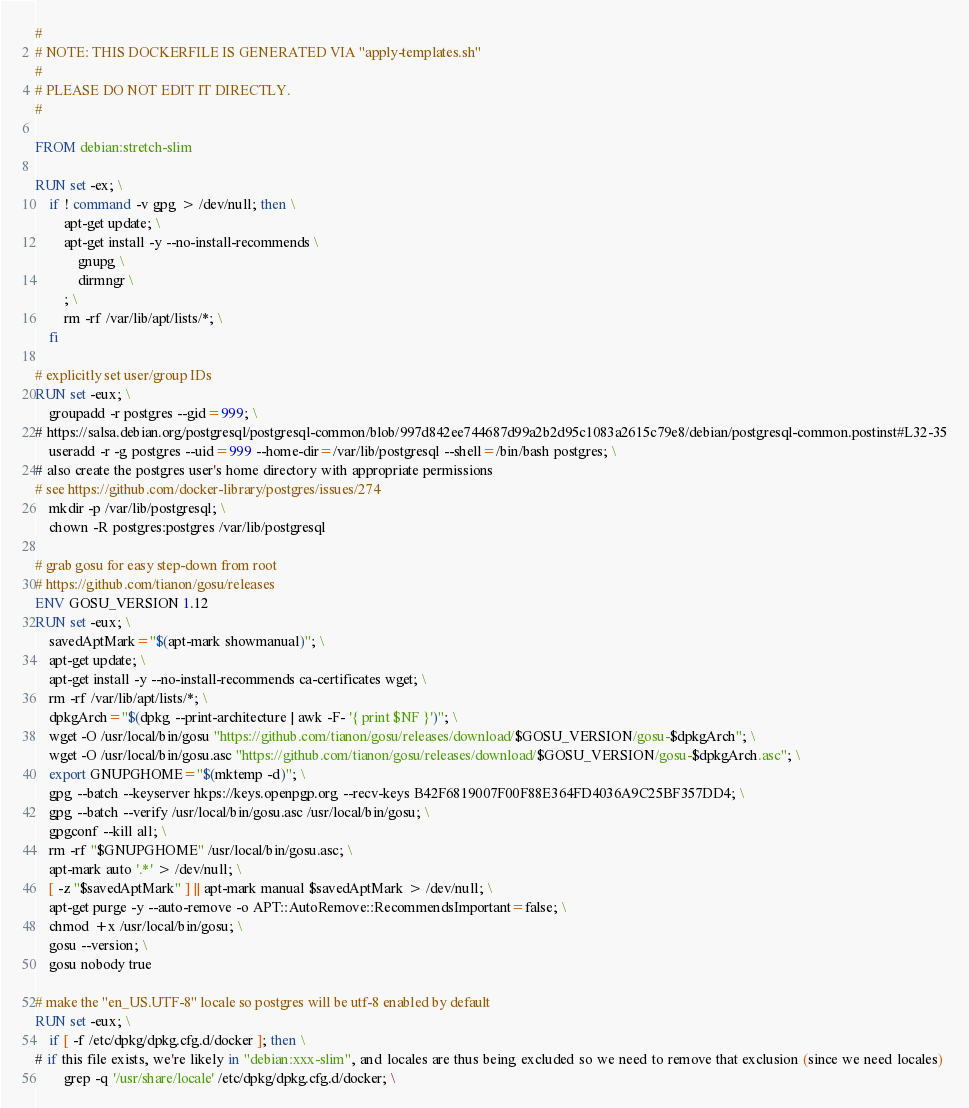<code> <loc_0><loc_0><loc_500><loc_500><_Dockerfile_>#
# NOTE: THIS DOCKERFILE IS GENERATED VIA "apply-templates.sh"
#
# PLEASE DO NOT EDIT IT DIRECTLY.
#

FROM debian:stretch-slim

RUN set -ex; \
	if ! command -v gpg > /dev/null; then \
		apt-get update; \
		apt-get install -y --no-install-recommends \
			gnupg \
			dirmngr \
		; \
		rm -rf /var/lib/apt/lists/*; \
	fi

# explicitly set user/group IDs
RUN set -eux; \
	groupadd -r postgres --gid=999; \
# https://salsa.debian.org/postgresql/postgresql-common/blob/997d842ee744687d99a2b2d95c1083a2615c79e8/debian/postgresql-common.postinst#L32-35
	useradd -r -g postgres --uid=999 --home-dir=/var/lib/postgresql --shell=/bin/bash postgres; \
# also create the postgres user's home directory with appropriate permissions
# see https://github.com/docker-library/postgres/issues/274
	mkdir -p /var/lib/postgresql; \
	chown -R postgres:postgres /var/lib/postgresql

# grab gosu for easy step-down from root
# https://github.com/tianon/gosu/releases
ENV GOSU_VERSION 1.12
RUN set -eux; \
	savedAptMark="$(apt-mark showmanual)"; \
	apt-get update; \
	apt-get install -y --no-install-recommends ca-certificates wget; \
	rm -rf /var/lib/apt/lists/*; \
	dpkgArch="$(dpkg --print-architecture | awk -F- '{ print $NF }')"; \
	wget -O /usr/local/bin/gosu "https://github.com/tianon/gosu/releases/download/$GOSU_VERSION/gosu-$dpkgArch"; \
	wget -O /usr/local/bin/gosu.asc "https://github.com/tianon/gosu/releases/download/$GOSU_VERSION/gosu-$dpkgArch.asc"; \
	export GNUPGHOME="$(mktemp -d)"; \
	gpg --batch --keyserver hkps://keys.openpgp.org --recv-keys B42F6819007F00F88E364FD4036A9C25BF357DD4; \
	gpg --batch --verify /usr/local/bin/gosu.asc /usr/local/bin/gosu; \
	gpgconf --kill all; \
	rm -rf "$GNUPGHOME" /usr/local/bin/gosu.asc; \
	apt-mark auto '.*' > /dev/null; \
	[ -z "$savedAptMark" ] || apt-mark manual $savedAptMark > /dev/null; \
	apt-get purge -y --auto-remove -o APT::AutoRemove::RecommendsImportant=false; \
	chmod +x /usr/local/bin/gosu; \
	gosu --version; \
	gosu nobody true

# make the "en_US.UTF-8" locale so postgres will be utf-8 enabled by default
RUN set -eux; \
	if [ -f /etc/dpkg/dpkg.cfg.d/docker ]; then \
# if this file exists, we're likely in "debian:xxx-slim", and locales are thus being excluded so we need to remove that exclusion (since we need locales)
		grep -q '/usr/share/locale' /etc/dpkg/dpkg.cfg.d/docker; \</code> 